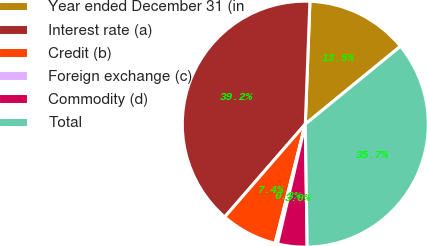<chart> <loc_0><loc_0><loc_500><loc_500><pie_chart><fcel>Year ended December 31 (in<fcel>Interest rate (a)<fcel>Credit (b)<fcel>Foreign exchange (c)<fcel>Commodity (d)<fcel>Total<nl><fcel>13.49%<fcel>39.22%<fcel>7.43%<fcel>0.32%<fcel>3.87%<fcel>35.67%<nl></chart> 